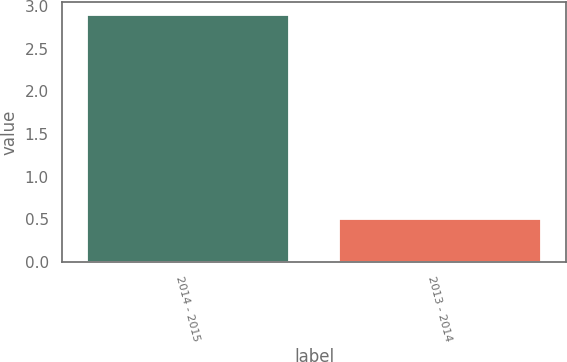Convert chart to OTSL. <chart><loc_0><loc_0><loc_500><loc_500><bar_chart><fcel>2014 - 2015<fcel>2013 - 2014<nl><fcel>2.9<fcel>0.5<nl></chart> 